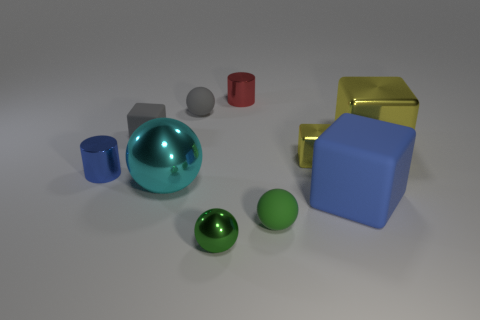Subtract all cyan metallic balls. How many balls are left? 3 Subtract all gray blocks. How many blocks are left? 3 Subtract 2 cubes. How many cubes are left? 2 Subtract all cyan blocks. Subtract all purple cylinders. How many blocks are left? 4 Subtract all balls. How many objects are left? 6 Subtract 1 green balls. How many objects are left? 9 Subtract all tiny green rubber cubes. Subtract all cubes. How many objects are left? 6 Add 1 red metallic cylinders. How many red metallic cylinders are left? 2 Add 5 tiny purple cylinders. How many tiny purple cylinders exist? 5 